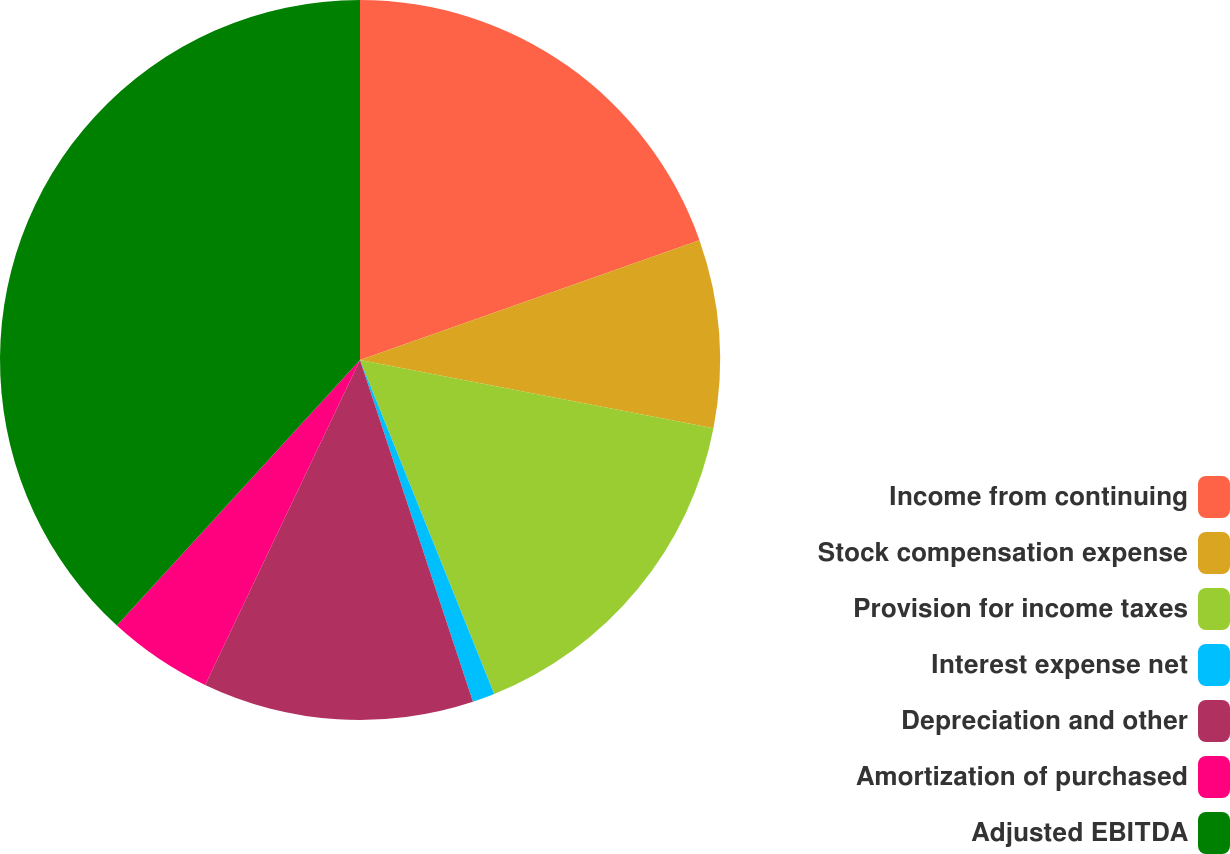Convert chart to OTSL. <chart><loc_0><loc_0><loc_500><loc_500><pie_chart><fcel>Income from continuing<fcel>Stock compensation expense<fcel>Provision for income taxes<fcel>Interest expense net<fcel>Depreciation and other<fcel>Amortization of purchased<fcel>Adjusted EBITDA<nl><fcel>19.6%<fcel>8.44%<fcel>15.88%<fcel>1.0%<fcel>12.16%<fcel>4.72%<fcel>38.2%<nl></chart> 